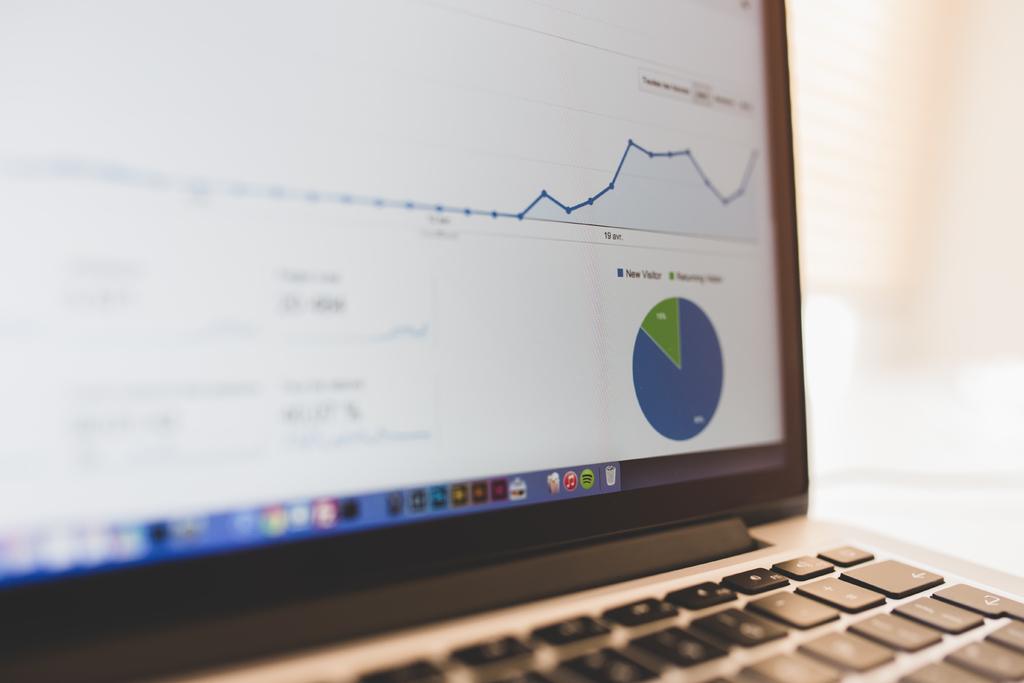What does the blue part of the pie chart represent?
Your answer should be very brief. New visitor. 